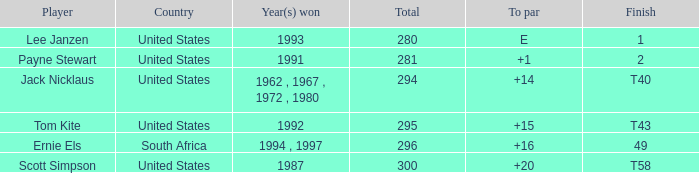Could you parse the entire table as a dict? {'header': ['Player', 'Country', 'Year(s) won', 'Total', 'To par', 'Finish'], 'rows': [['Lee Janzen', 'United States', '1993', '280', 'E', '1'], ['Payne Stewart', 'United States', '1991', '281', '+1', '2'], ['Jack Nicklaus', 'United States', '1962 , 1967 , 1972 , 1980', '294', '+14', 'T40'], ['Tom Kite', 'United States', '1992', '295', '+15', 'T43'], ['Ernie Els', 'South Africa', '1994 , 1997', '296', '+16', '49'], ['Scott Simpson', 'United States', '1987', '300', '+20', 'T58']]} What Country is Tom Kite from? United States. 